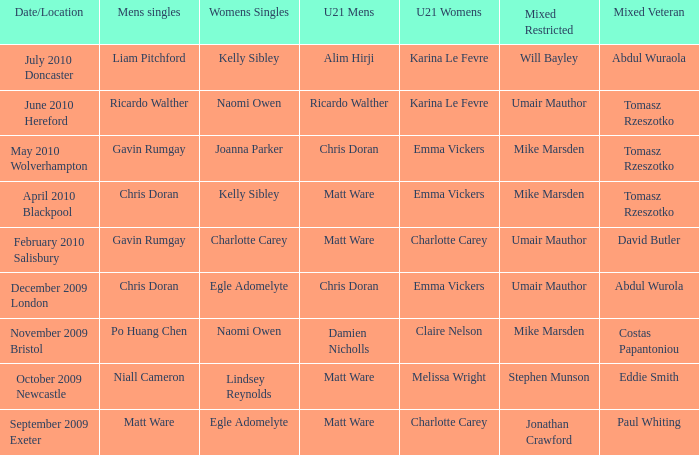Who won the mixed restricted when Tomasz Rzeszotko won the mixed veteran and Karina Le Fevre won the U21 womens? Umair Mauthor. 